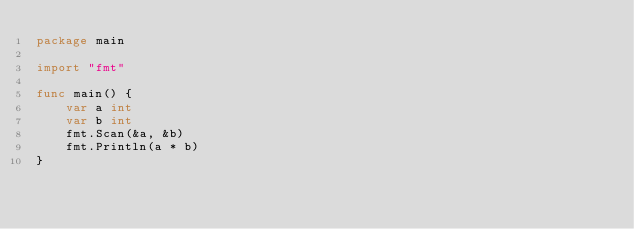<code> <loc_0><loc_0><loc_500><loc_500><_Go_>package main

import "fmt"

func main() {
	var a int
	var b int
	fmt.Scan(&a, &b)
	fmt.Println(a * b)
}</code> 